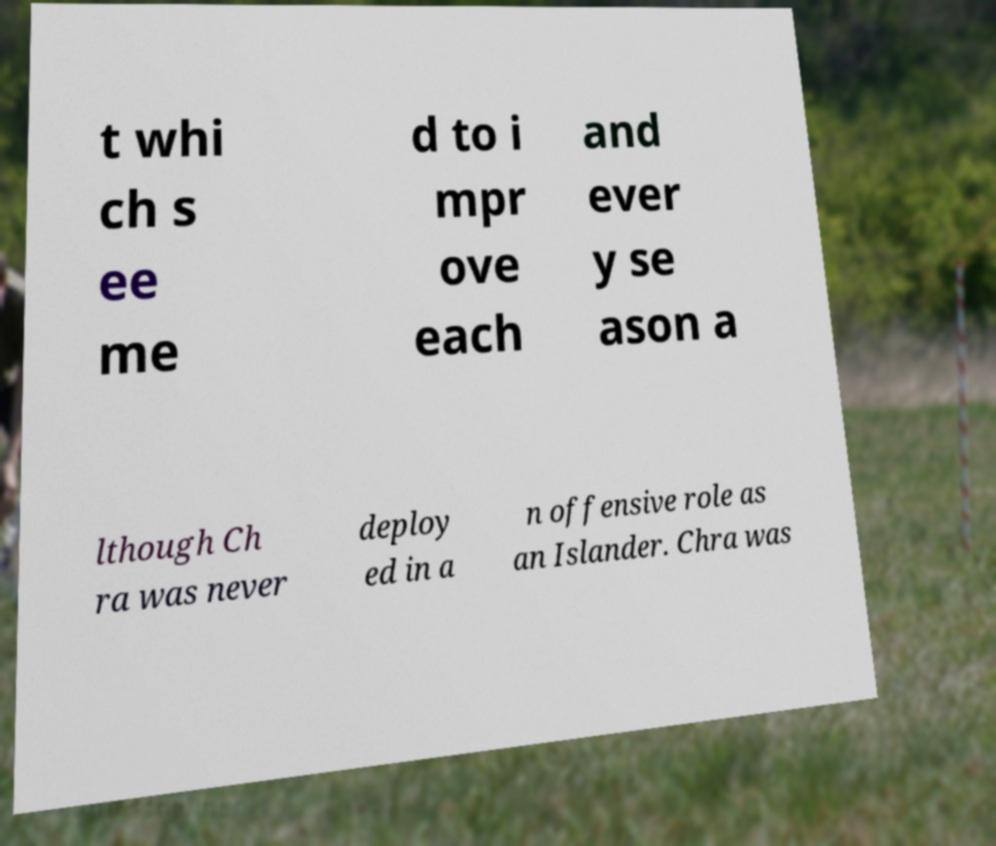Can you read and provide the text displayed in the image?This photo seems to have some interesting text. Can you extract and type it out for me? t whi ch s ee me d to i mpr ove each and ever y se ason a lthough Ch ra was never deploy ed in a n offensive role as an Islander. Chra was 